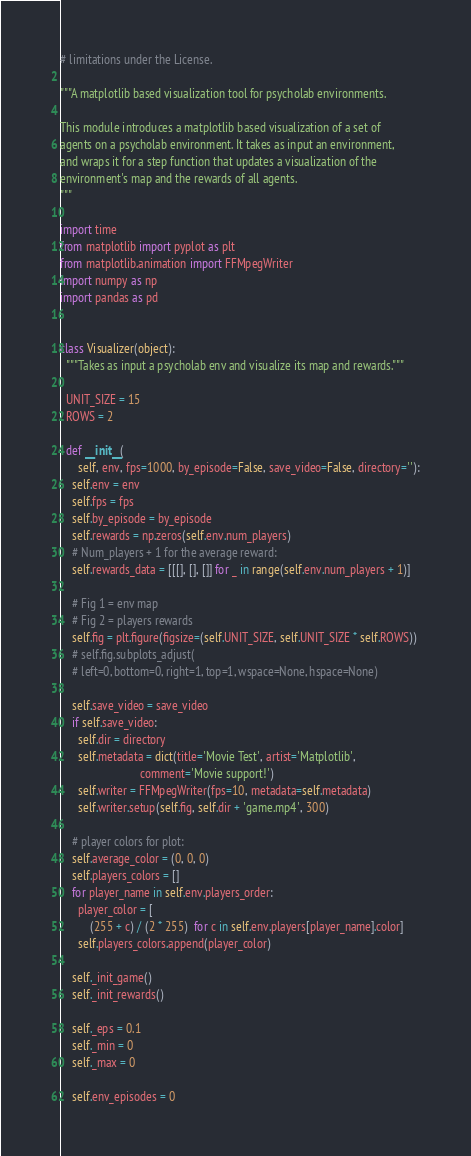<code> <loc_0><loc_0><loc_500><loc_500><_Python_># limitations under the License.

"""A matplotlib based visualization tool for psycholab environments.

This module introduces a matplotlib based visualization of a set of
agents on a psycholab environment. It takes as input an environment,
and wraps it for a step function that updates a visualization of the
environment's map and the rewards of all agents.
"""

import time
from matplotlib import pyplot as plt
from matplotlib.animation import FFMpegWriter
import numpy as np
import pandas as pd


class Visualizer(object):
  """Takes as input a psycholab env and visualize its map and rewards."""

  UNIT_SIZE = 15
  ROWS = 2

  def __init__(
      self, env, fps=1000, by_episode=False, save_video=False, directory=''):
    self.env = env
    self.fps = fps
    self.by_episode = by_episode
    self.rewards = np.zeros(self.env.num_players)
    # Num_players + 1 for the average reward:
    self.rewards_data = [[[], [], []] for _ in range(self.env.num_players + 1)]

    # Fig 1 = env map
    # Fig 2 = players rewards
    self.fig = plt.figure(figsize=(self.UNIT_SIZE, self.UNIT_SIZE * self.ROWS))
    # self.fig.subplots_adjust(
    # left=0, bottom=0, right=1, top=1, wspace=None, hspace=None)

    self.save_video = save_video
    if self.save_video:
      self.dir = directory
      self.metadata = dict(title='Movie Test', artist='Matplotlib',
                           comment='Movie support!')
      self.writer = FFMpegWriter(fps=10, metadata=self.metadata)
      self.writer.setup(self.fig, self.dir + 'game.mp4', 300)

    # player colors for plot:
    self.average_color = (0, 0, 0)
    self.players_colors = []
    for player_name in self.env.players_order:
      player_color = [
          (255 + c) / (2 * 255)  for c in self.env.players[player_name].color]
      self.players_colors.append(player_color)

    self._init_game()
    self._init_rewards()

    self._eps = 0.1
    self._min = 0
    self._max = 0

    self.env_episodes = 0</code> 